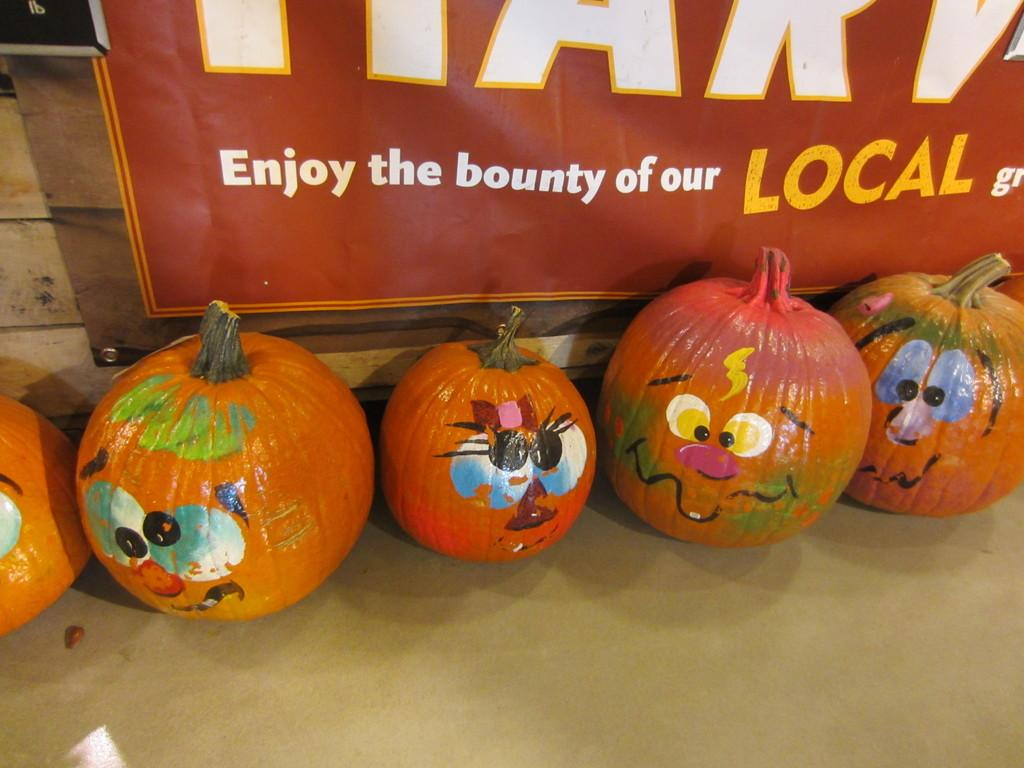What type of objects can be seen in the image? There are pumpkins in the image. What is unique about the appearance of the pumpkins? The pumpkins have paintings on them. What can be seen in the background of the image? There is a board with text in the background of the image. Can you see any clouds or ships in the image? No, there are no clouds or ships present in the image. How many pumpkins are flying in the image? There are no pumpkins flying in the image; they are stationary on the ground. 